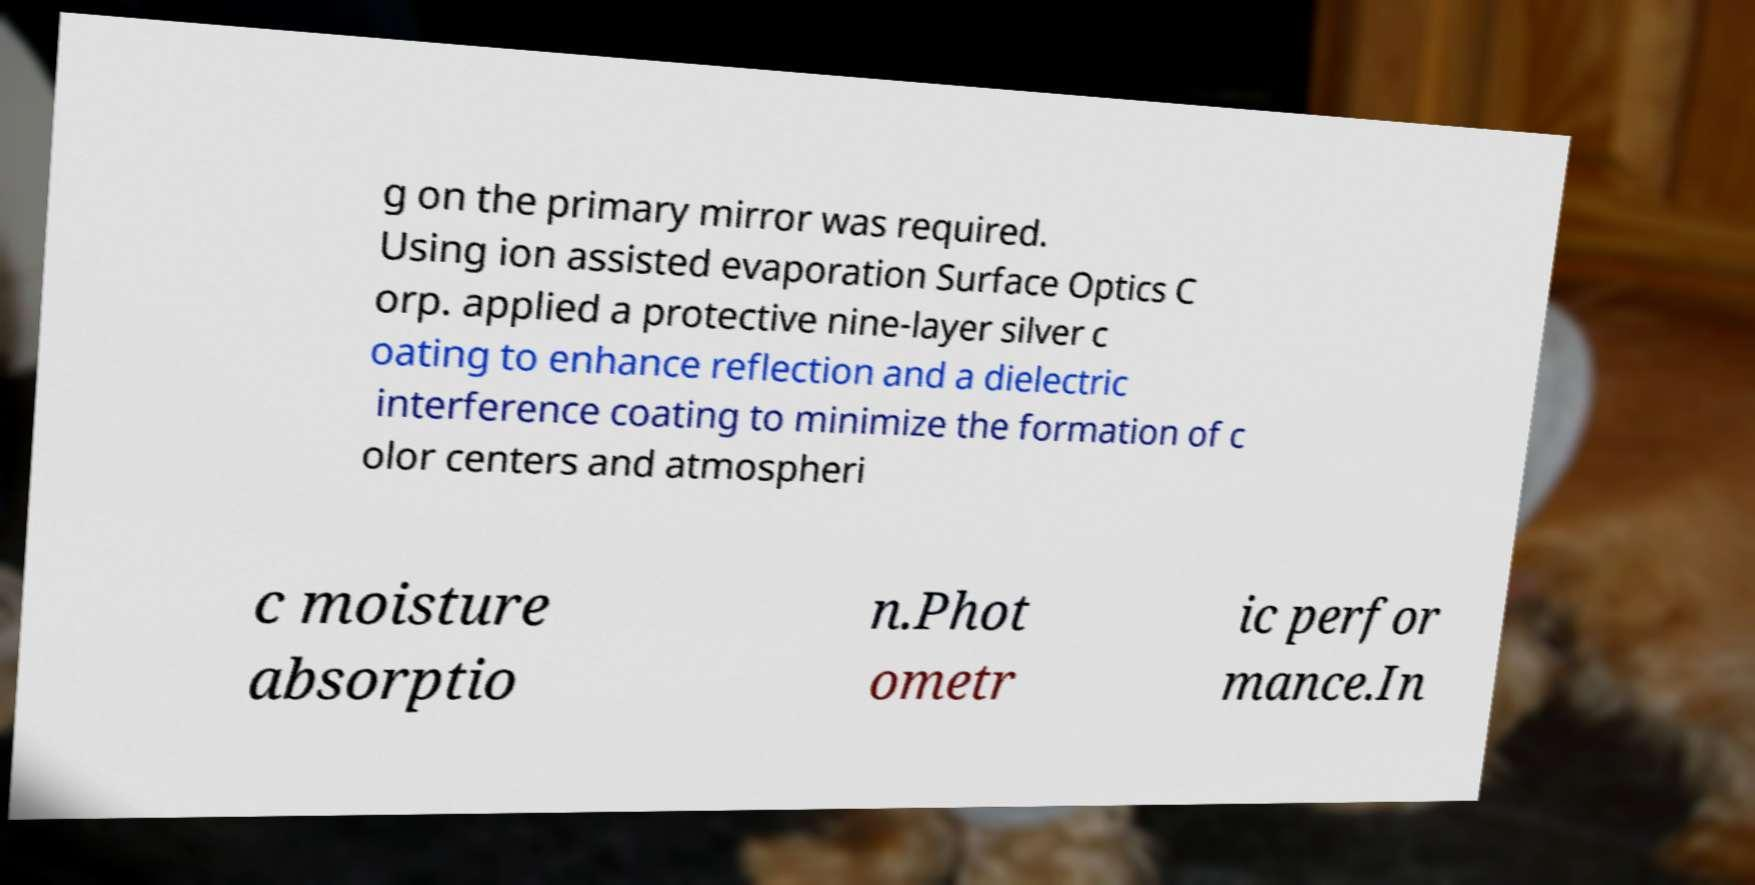Can you accurately transcribe the text from the provided image for me? g on the primary mirror was required. Using ion assisted evaporation Surface Optics C orp. applied a protective nine-layer silver c oating to enhance reflection and a dielectric interference coating to minimize the formation of c olor centers and atmospheri c moisture absorptio n.Phot ometr ic perfor mance.In 